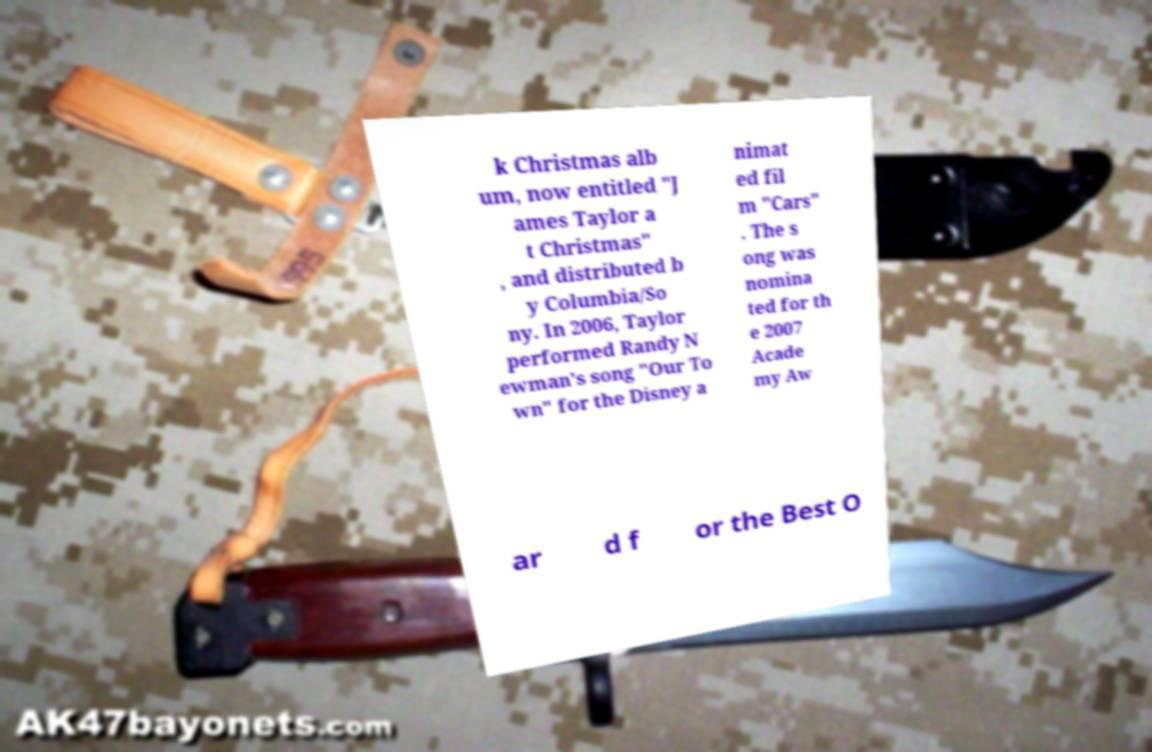Could you assist in decoding the text presented in this image and type it out clearly? k Christmas alb um, now entitled "J ames Taylor a t Christmas" , and distributed b y Columbia/So ny. In 2006, Taylor performed Randy N ewman's song "Our To wn" for the Disney a nimat ed fil m "Cars" . The s ong was nomina ted for th e 2007 Acade my Aw ar d f or the Best O 